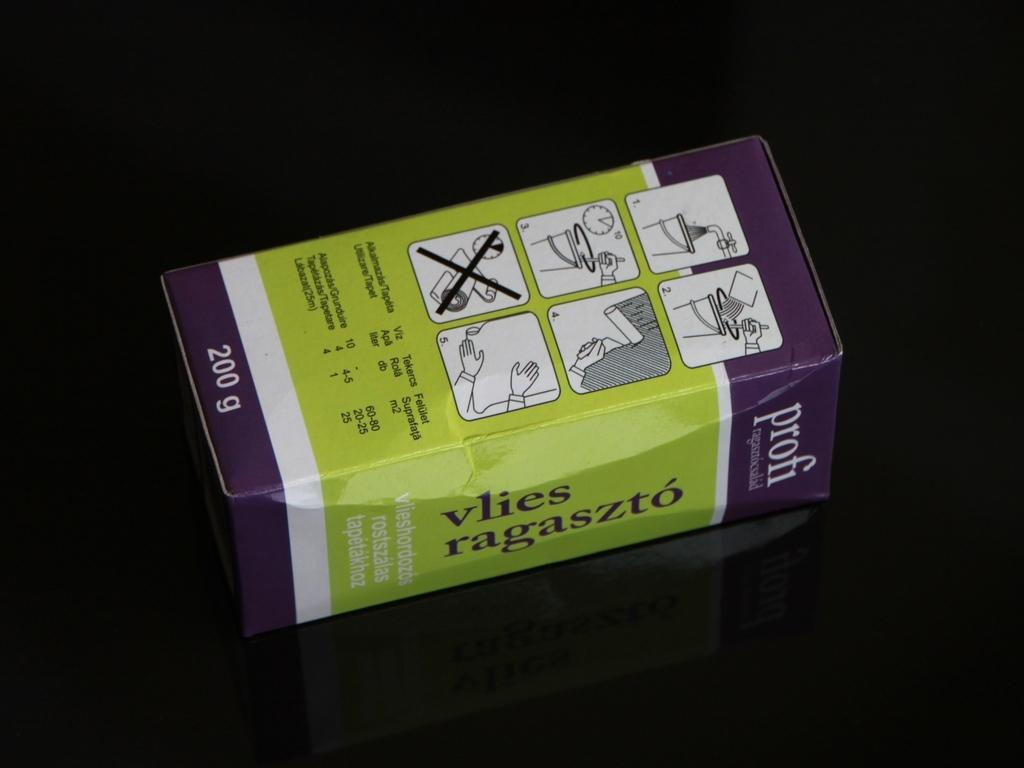<image>
Offer a succinct explanation of the picture presented. 200 g vlies ragaszto is printed on the side of this box. 